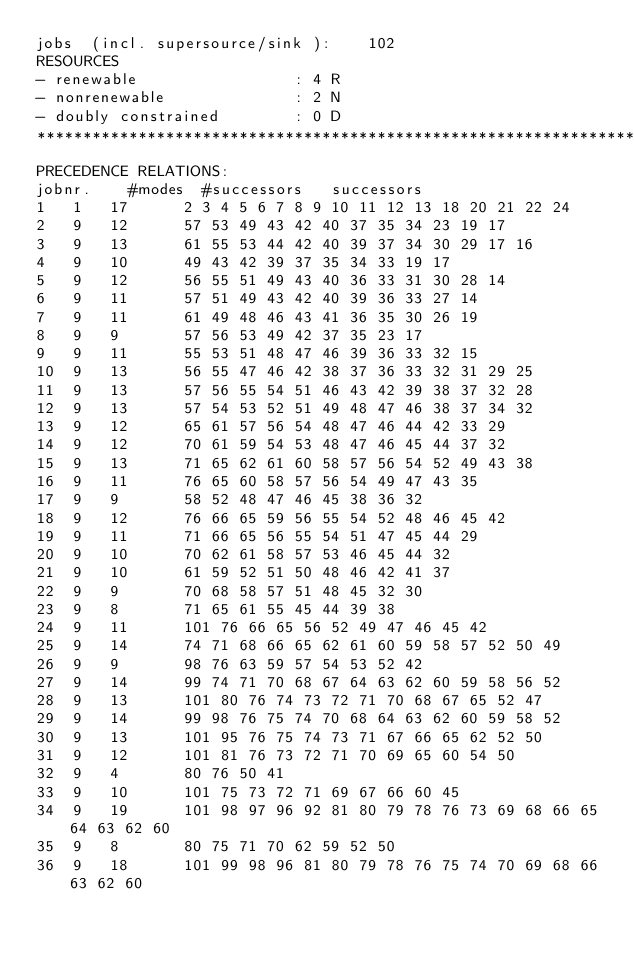Convert code to text. <code><loc_0><loc_0><loc_500><loc_500><_ObjectiveC_>jobs  (incl. supersource/sink ):	102
RESOURCES
- renewable                 : 4 R
- nonrenewable              : 2 N
- doubly constrained        : 0 D
************************************************************************
PRECEDENCE RELATIONS:
jobnr.    #modes  #successors   successors
1	1	17		2 3 4 5 6 7 8 9 10 11 12 13 18 20 21 22 24 
2	9	12		57 53 49 43 42 40 37 35 34 23 19 17 
3	9	13		61 55 53 44 42 40 39 37 34 30 29 17 16 
4	9	10		49 43 42 39 37 35 34 33 19 17 
5	9	12		56 55 51 49 43 40 36 33 31 30 28 14 
6	9	11		57 51 49 43 42 40 39 36 33 27 14 
7	9	11		61 49 48 46 43 41 36 35 30 26 19 
8	9	9		57 56 53 49 42 37 35 23 17 
9	9	11		55 53 51 48 47 46 39 36 33 32 15 
10	9	13		56 55 47 46 42 38 37 36 33 32 31 29 25 
11	9	13		57 56 55 54 51 46 43 42 39 38 37 32 28 
12	9	13		57 54 53 52 51 49 48 47 46 38 37 34 32 
13	9	12		65 61 57 56 54 48 47 46 44 42 33 29 
14	9	12		70 61 59 54 53 48 47 46 45 44 37 32 
15	9	13		71 65 62 61 60 58 57 56 54 52 49 43 38 
16	9	11		76 65 60 58 57 56 54 49 47 43 35 
17	9	9		58 52 48 47 46 45 38 36 32 
18	9	12		76 66 65 59 56 55 54 52 48 46 45 42 
19	9	11		71 66 65 56 55 54 51 47 45 44 29 
20	9	10		70 62 61 58 57 53 46 45 44 32 
21	9	10		61 59 52 51 50 48 46 42 41 37 
22	9	9		70 68 58 57 51 48 45 32 30 
23	9	8		71 65 61 55 45 44 39 38 
24	9	11		101 76 66 65 56 52 49 47 46 45 42 
25	9	14		74 71 68 66 65 62 61 60 59 58 57 52 50 49 
26	9	9		98 76 63 59 57 54 53 52 42 
27	9	14		99 74 71 70 68 67 64 63 62 60 59 58 56 52 
28	9	13		101 80 76 74 73 72 71 70 68 67 65 52 47 
29	9	14		99 98 76 75 74 70 68 64 63 62 60 59 58 52 
30	9	13		101 95 76 75 74 73 71 67 66 65 62 52 50 
31	9	12		101 81 76 73 72 71 70 69 65 60 54 50 
32	9	4		80 76 50 41 
33	9	10		101 75 73 72 71 69 67 66 60 45 
34	9	19		101 98 97 96 92 81 80 79 78 76 73 69 68 66 65 64 63 62 60 
35	9	8		80 75 71 70 62 59 52 50 
36	9	18		101 99 98 96 81 80 79 78 76 75 74 70 69 68 66 63 62 60 </code> 